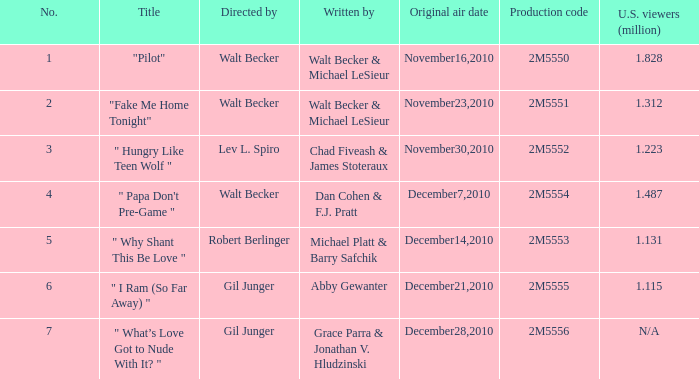How many million U.S. viewers saw "Fake Me Home Tonight"? 1.312. 